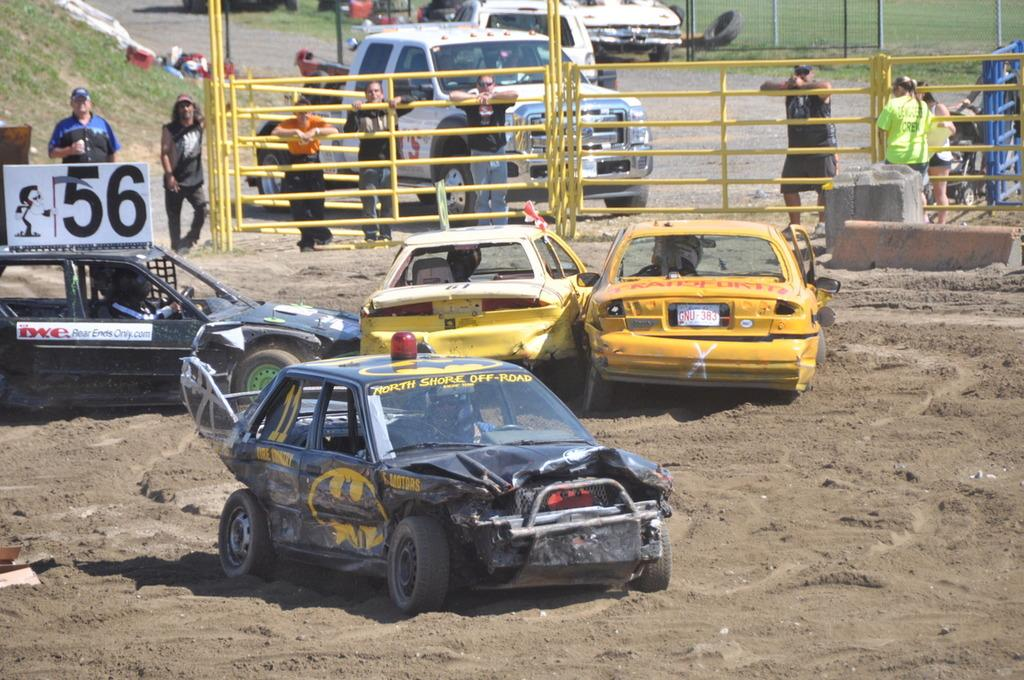What is the main subject of the image? The main subject of the image is many cars on the ground. What can be seen in the background of the image? In the background of the image, there is fencing, persons, cars, grass, poles, and a road. How many cars are visible in the image? There are many cars visible in the image, both on the ground and in the background. What type of underwear are the friends wearing in the image? There are no friends or underwear present in the image; it features cars on the ground and various elements in the background. 